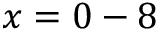Convert formula to latex. <formula><loc_0><loc_0><loc_500><loc_500>x = 0 - 8</formula> 